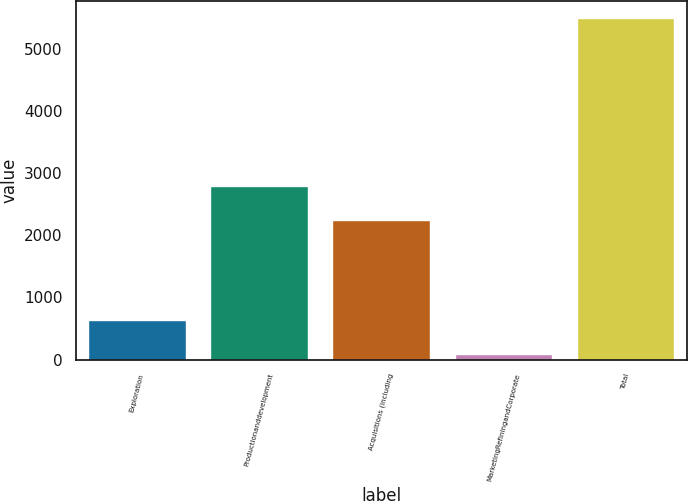Convert chart to OTSL. <chart><loc_0><loc_0><loc_500><loc_500><bar_chart><fcel>Exploration<fcel>Productionanddevelopment<fcel>Acquisitions (including<fcel>MarketingRefiningandCorporate<fcel>Total<nl><fcel>637.4<fcel>2789.4<fcel>2250<fcel>98<fcel>5492<nl></chart> 